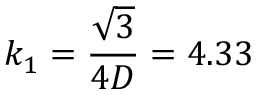Convert formula to latex. <formula><loc_0><loc_0><loc_500><loc_500>k _ { 1 } = \frac { \sqrt { 3 } } { 4 D } = 4 . 3 3</formula> 